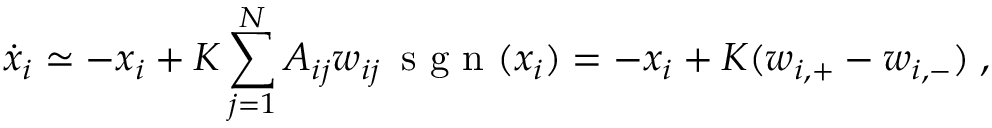<formula> <loc_0><loc_0><loc_500><loc_500>\dot { x } _ { i } \simeq - x _ { i } + K \sum _ { j = 1 } ^ { N } A _ { i j } w _ { i j } \, s g n ( x _ { i } ) = - x _ { i } + K ( w _ { i , + } - w _ { i , - } ) \, ,</formula> 